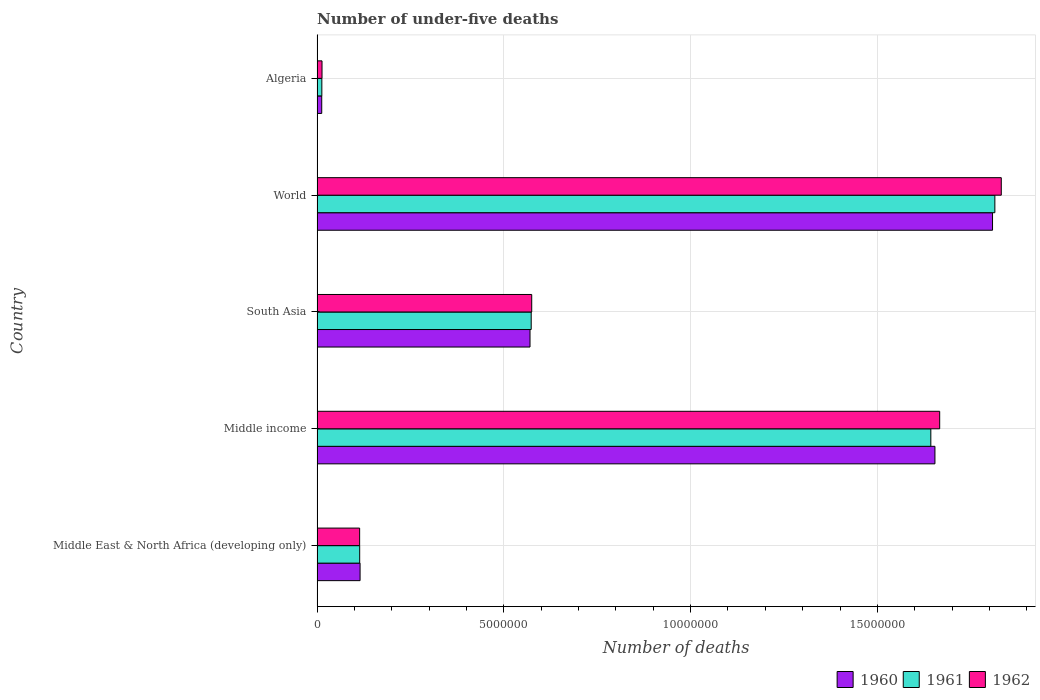How many groups of bars are there?
Make the answer very short. 5. Are the number of bars on each tick of the Y-axis equal?
Provide a short and direct response. Yes. How many bars are there on the 4th tick from the bottom?
Provide a short and direct response. 3. In how many cases, is the number of bars for a given country not equal to the number of legend labels?
Your answer should be compact. 0. What is the number of under-five deaths in 1960 in South Asia?
Your response must be concise. 5.70e+06. Across all countries, what is the maximum number of under-five deaths in 1962?
Provide a short and direct response. 1.83e+07. Across all countries, what is the minimum number of under-five deaths in 1961?
Offer a very short reply. 1.28e+05. In which country was the number of under-five deaths in 1961 maximum?
Your answer should be very brief. World. In which country was the number of under-five deaths in 1960 minimum?
Offer a terse response. Algeria. What is the total number of under-five deaths in 1960 in the graph?
Provide a short and direct response. 4.16e+07. What is the difference between the number of under-five deaths in 1960 in Middle East & North Africa (developing only) and that in World?
Your answer should be very brief. -1.69e+07. What is the difference between the number of under-five deaths in 1962 in Middle income and the number of under-five deaths in 1960 in World?
Give a very brief answer. -1.41e+06. What is the average number of under-five deaths in 1961 per country?
Provide a short and direct response. 8.32e+06. What is the difference between the number of under-five deaths in 1962 and number of under-five deaths in 1960 in Middle income?
Make the answer very short. 1.27e+05. In how many countries, is the number of under-five deaths in 1961 greater than 18000000 ?
Provide a succinct answer. 1. What is the ratio of the number of under-five deaths in 1961 in South Asia to that in World?
Make the answer very short. 0.32. Is the difference between the number of under-five deaths in 1962 in Middle East & North Africa (developing only) and Middle income greater than the difference between the number of under-five deaths in 1960 in Middle East & North Africa (developing only) and Middle income?
Ensure brevity in your answer.  No. What is the difference between the highest and the second highest number of under-five deaths in 1961?
Keep it short and to the point. 1.71e+06. What is the difference between the highest and the lowest number of under-five deaths in 1960?
Provide a succinct answer. 1.80e+07. In how many countries, is the number of under-five deaths in 1960 greater than the average number of under-five deaths in 1960 taken over all countries?
Give a very brief answer. 2. What does the 2nd bar from the top in Algeria represents?
Ensure brevity in your answer.  1961. Is it the case that in every country, the sum of the number of under-five deaths in 1961 and number of under-five deaths in 1960 is greater than the number of under-five deaths in 1962?
Provide a succinct answer. Yes. Are all the bars in the graph horizontal?
Make the answer very short. Yes. How many countries are there in the graph?
Ensure brevity in your answer.  5. Are the values on the major ticks of X-axis written in scientific E-notation?
Provide a short and direct response. No. How many legend labels are there?
Your answer should be compact. 3. What is the title of the graph?
Provide a succinct answer. Number of under-five deaths. What is the label or title of the X-axis?
Provide a short and direct response. Number of deaths. What is the label or title of the Y-axis?
Offer a very short reply. Country. What is the Number of deaths of 1960 in Middle East & North Africa (developing only)?
Provide a short and direct response. 1.15e+06. What is the Number of deaths in 1961 in Middle East & North Africa (developing only)?
Ensure brevity in your answer.  1.14e+06. What is the Number of deaths in 1962 in Middle East & North Africa (developing only)?
Your answer should be very brief. 1.14e+06. What is the Number of deaths in 1960 in Middle income?
Provide a succinct answer. 1.65e+07. What is the Number of deaths in 1961 in Middle income?
Keep it short and to the point. 1.64e+07. What is the Number of deaths in 1962 in Middle income?
Keep it short and to the point. 1.67e+07. What is the Number of deaths of 1960 in South Asia?
Make the answer very short. 5.70e+06. What is the Number of deaths of 1961 in South Asia?
Offer a very short reply. 5.73e+06. What is the Number of deaths of 1962 in South Asia?
Give a very brief answer. 5.75e+06. What is the Number of deaths in 1960 in World?
Keep it short and to the point. 1.81e+07. What is the Number of deaths of 1961 in World?
Your response must be concise. 1.81e+07. What is the Number of deaths of 1962 in World?
Offer a very short reply. 1.83e+07. What is the Number of deaths of 1960 in Algeria?
Keep it short and to the point. 1.25e+05. What is the Number of deaths of 1961 in Algeria?
Make the answer very short. 1.28e+05. What is the Number of deaths in 1962 in Algeria?
Provide a short and direct response. 1.33e+05. Across all countries, what is the maximum Number of deaths of 1960?
Make the answer very short. 1.81e+07. Across all countries, what is the maximum Number of deaths in 1961?
Keep it short and to the point. 1.81e+07. Across all countries, what is the maximum Number of deaths in 1962?
Ensure brevity in your answer.  1.83e+07. Across all countries, what is the minimum Number of deaths of 1960?
Your answer should be compact. 1.25e+05. Across all countries, what is the minimum Number of deaths of 1961?
Keep it short and to the point. 1.28e+05. Across all countries, what is the minimum Number of deaths of 1962?
Keep it short and to the point. 1.33e+05. What is the total Number of deaths of 1960 in the graph?
Give a very brief answer. 4.16e+07. What is the total Number of deaths of 1961 in the graph?
Keep it short and to the point. 4.16e+07. What is the total Number of deaths in 1962 in the graph?
Your answer should be compact. 4.20e+07. What is the difference between the Number of deaths of 1960 in Middle East & North Africa (developing only) and that in Middle income?
Offer a terse response. -1.54e+07. What is the difference between the Number of deaths of 1961 in Middle East & North Africa (developing only) and that in Middle income?
Offer a very short reply. -1.53e+07. What is the difference between the Number of deaths in 1962 in Middle East & North Africa (developing only) and that in Middle income?
Keep it short and to the point. -1.55e+07. What is the difference between the Number of deaths of 1960 in Middle East & North Africa (developing only) and that in South Asia?
Ensure brevity in your answer.  -4.55e+06. What is the difference between the Number of deaths of 1961 in Middle East & North Africa (developing only) and that in South Asia?
Provide a short and direct response. -4.59e+06. What is the difference between the Number of deaths in 1962 in Middle East & North Africa (developing only) and that in South Asia?
Provide a succinct answer. -4.61e+06. What is the difference between the Number of deaths of 1960 in Middle East & North Africa (developing only) and that in World?
Offer a terse response. -1.69e+07. What is the difference between the Number of deaths of 1961 in Middle East & North Africa (developing only) and that in World?
Give a very brief answer. -1.70e+07. What is the difference between the Number of deaths in 1962 in Middle East & North Africa (developing only) and that in World?
Provide a succinct answer. -1.72e+07. What is the difference between the Number of deaths of 1960 in Middle East & North Africa (developing only) and that in Algeria?
Provide a short and direct response. 1.03e+06. What is the difference between the Number of deaths in 1961 in Middle East & North Africa (developing only) and that in Algeria?
Offer a terse response. 1.01e+06. What is the difference between the Number of deaths in 1962 in Middle East & North Africa (developing only) and that in Algeria?
Ensure brevity in your answer.  1.01e+06. What is the difference between the Number of deaths of 1960 in Middle income and that in South Asia?
Your answer should be very brief. 1.08e+07. What is the difference between the Number of deaths of 1961 in Middle income and that in South Asia?
Give a very brief answer. 1.07e+07. What is the difference between the Number of deaths in 1962 in Middle income and that in South Asia?
Your response must be concise. 1.09e+07. What is the difference between the Number of deaths in 1960 in Middle income and that in World?
Your response must be concise. -1.54e+06. What is the difference between the Number of deaths of 1961 in Middle income and that in World?
Make the answer very short. -1.71e+06. What is the difference between the Number of deaths of 1962 in Middle income and that in World?
Offer a very short reply. -1.65e+06. What is the difference between the Number of deaths of 1960 in Middle income and that in Algeria?
Provide a succinct answer. 1.64e+07. What is the difference between the Number of deaths of 1961 in Middle income and that in Algeria?
Provide a short and direct response. 1.63e+07. What is the difference between the Number of deaths of 1962 in Middle income and that in Algeria?
Make the answer very short. 1.65e+07. What is the difference between the Number of deaths of 1960 in South Asia and that in World?
Your answer should be compact. -1.24e+07. What is the difference between the Number of deaths of 1961 in South Asia and that in World?
Ensure brevity in your answer.  -1.24e+07. What is the difference between the Number of deaths of 1962 in South Asia and that in World?
Make the answer very short. -1.26e+07. What is the difference between the Number of deaths of 1960 in South Asia and that in Algeria?
Your answer should be very brief. 5.58e+06. What is the difference between the Number of deaths in 1961 in South Asia and that in Algeria?
Offer a very short reply. 5.60e+06. What is the difference between the Number of deaths of 1962 in South Asia and that in Algeria?
Offer a terse response. 5.61e+06. What is the difference between the Number of deaths in 1960 in World and that in Algeria?
Make the answer very short. 1.80e+07. What is the difference between the Number of deaths in 1961 in World and that in Algeria?
Offer a very short reply. 1.80e+07. What is the difference between the Number of deaths in 1962 in World and that in Algeria?
Your response must be concise. 1.82e+07. What is the difference between the Number of deaths of 1960 in Middle East & North Africa (developing only) and the Number of deaths of 1961 in Middle income?
Provide a short and direct response. -1.53e+07. What is the difference between the Number of deaths in 1960 in Middle East & North Africa (developing only) and the Number of deaths in 1962 in Middle income?
Your answer should be very brief. -1.55e+07. What is the difference between the Number of deaths of 1961 in Middle East & North Africa (developing only) and the Number of deaths of 1962 in Middle income?
Offer a terse response. -1.55e+07. What is the difference between the Number of deaths in 1960 in Middle East & North Africa (developing only) and the Number of deaths in 1961 in South Asia?
Provide a succinct answer. -4.58e+06. What is the difference between the Number of deaths of 1960 in Middle East & North Africa (developing only) and the Number of deaths of 1962 in South Asia?
Make the answer very short. -4.59e+06. What is the difference between the Number of deaths of 1961 in Middle East & North Africa (developing only) and the Number of deaths of 1962 in South Asia?
Provide a short and direct response. -4.61e+06. What is the difference between the Number of deaths in 1960 in Middle East & North Africa (developing only) and the Number of deaths in 1961 in World?
Offer a very short reply. -1.70e+07. What is the difference between the Number of deaths of 1960 in Middle East & North Africa (developing only) and the Number of deaths of 1962 in World?
Make the answer very short. -1.72e+07. What is the difference between the Number of deaths in 1961 in Middle East & North Africa (developing only) and the Number of deaths in 1962 in World?
Make the answer very short. -1.72e+07. What is the difference between the Number of deaths of 1960 in Middle East & North Africa (developing only) and the Number of deaths of 1961 in Algeria?
Your answer should be very brief. 1.02e+06. What is the difference between the Number of deaths in 1960 in Middle East & North Africa (developing only) and the Number of deaths in 1962 in Algeria?
Offer a very short reply. 1.02e+06. What is the difference between the Number of deaths of 1961 in Middle East & North Africa (developing only) and the Number of deaths of 1962 in Algeria?
Make the answer very short. 1.01e+06. What is the difference between the Number of deaths in 1960 in Middle income and the Number of deaths in 1961 in South Asia?
Make the answer very short. 1.08e+07. What is the difference between the Number of deaths in 1960 in Middle income and the Number of deaths in 1962 in South Asia?
Provide a succinct answer. 1.08e+07. What is the difference between the Number of deaths of 1961 in Middle income and the Number of deaths of 1962 in South Asia?
Give a very brief answer. 1.07e+07. What is the difference between the Number of deaths of 1960 in Middle income and the Number of deaths of 1961 in World?
Your response must be concise. -1.60e+06. What is the difference between the Number of deaths of 1960 in Middle income and the Number of deaths of 1962 in World?
Make the answer very short. -1.78e+06. What is the difference between the Number of deaths of 1961 in Middle income and the Number of deaths of 1962 in World?
Keep it short and to the point. -1.89e+06. What is the difference between the Number of deaths in 1960 in Middle income and the Number of deaths in 1961 in Algeria?
Your answer should be compact. 1.64e+07. What is the difference between the Number of deaths in 1960 in Middle income and the Number of deaths in 1962 in Algeria?
Offer a terse response. 1.64e+07. What is the difference between the Number of deaths of 1961 in Middle income and the Number of deaths of 1962 in Algeria?
Offer a terse response. 1.63e+07. What is the difference between the Number of deaths in 1960 in South Asia and the Number of deaths in 1961 in World?
Your answer should be compact. -1.24e+07. What is the difference between the Number of deaths of 1960 in South Asia and the Number of deaths of 1962 in World?
Offer a very short reply. -1.26e+07. What is the difference between the Number of deaths of 1961 in South Asia and the Number of deaths of 1962 in World?
Make the answer very short. -1.26e+07. What is the difference between the Number of deaths in 1960 in South Asia and the Number of deaths in 1961 in Algeria?
Offer a very short reply. 5.57e+06. What is the difference between the Number of deaths in 1960 in South Asia and the Number of deaths in 1962 in Algeria?
Your answer should be compact. 5.57e+06. What is the difference between the Number of deaths of 1961 in South Asia and the Number of deaths of 1962 in Algeria?
Your response must be concise. 5.60e+06. What is the difference between the Number of deaths in 1960 in World and the Number of deaths in 1961 in Algeria?
Make the answer very short. 1.80e+07. What is the difference between the Number of deaths in 1960 in World and the Number of deaths in 1962 in Algeria?
Provide a succinct answer. 1.80e+07. What is the difference between the Number of deaths of 1961 in World and the Number of deaths of 1962 in Algeria?
Ensure brevity in your answer.  1.80e+07. What is the average Number of deaths of 1960 per country?
Your response must be concise. 8.32e+06. What is the average Number of deaths of 1961 per country?
Offer a terse response. 8.32e+06. What is the average Number of deaths of 1962 per country?
Offer a terse response. 8.40e+06. What is the difference between the Number of deaths in 1960 and Number of deaths in 1961 in Middle East & North Africa (developing only)?
Offer a terse response. 1.05e+04. What is the difference between the Number of deaths of 1960 and Number of deaths of 1962 in Middle East & North Africa (developing only)?
Keep it short and to the point. 1.18e+04. What is the difference between the Number of deaths of 1961 and Number of deaths of 1962 in Middle East & North Africa (developing only)?
Your answer should be compact. 1336. What is the difference between the Number of deaths in 1960 and Number of deaths in 1961 in Middle income?
Ensure brevity in your answer.  1.10e+05. What is the difference between the Number of deaths in 1960 and Number of deaths in 1962 in Middle income?
Offer a very short reply. -1.27e+05. What is the difference between the Number of deaths in 1961 and Number of deaths in 1962 in Middle income?
Your answer should be very brief. -2.37e+05. What is the difference between the Number of deaths of 1960 and Number of deaths of 1961 in South Asia?
Your response must be concise. -3.16e+04. What is the difference between the Number of deaths of 1960 and Number of deaths of 1962 in South Asia?
Give a very brief answer. -4.54e+04. What is the difference between the Number of deaths of 1961 and Number of deaths of 1962 in South Asia?
Your response must be concise. -1.37e+04. What is the difference between the Number of deaths of 1960 and Number of deaths of 1961 in World?
Keep it short and to the point. -6.21e+04. What is the difference between the Number of deaths of 1960 and Number of deaths of 1962 in World?
Make the answer very short. -2.34e+05. What is the difference between the Number of deaths in 1961 and Number of deaths in 1962 in World?
Give a very brief answer. -1.72e+05. What is the difference between the Number of deaths of 1960 and Number of deaths of 1961 in Algeria?
Provide a succinct answer. -2789. What is the difference between the Number of deaths in 1960 and Number of deaths in 1962 in Algeria?
Give a very brief answer. -7580. What is the difference between the Number of deaths of 1961 and Number of deaths of 1962 in Algeria?
Provide a succinct answer. -4791. What is the ratio of the Number of deaths in 1960 in Middle East & North Africa (developing only) to that in Middle income?
Provide a succinct answer. 0.07. What is the ratio of the Number of deaths in 1961 in Middle East & North Africa (developing only) to that in Middle income?
Provide a short and direct response. 0.07. What is the ratio of the Number of deaths in 1962 in Middle East & North Africa (developing only) to that in Middle income?
Your answer should be compact. 0.07. What is the ratio of the Number of deaths in 1960 in Middle East & North Africa (developing only) to that in South Asia?
Provide a succinct answer. 0.2. What is the ratio of the Number of deaths of 1961 in Middle East & North Africa (developing only) to that in South Asia?
Offer a terse response. 0.2. What is the ratio of the Number of deaths of 1962 in Middle East & North Africa (developing only) to that in South Asia?
Your answer should be very brief. 0.2. What is the ratio of the Number of deaths of 1960 in Middle East & North Africa (developing only) to that in World?
Your answer should be compact. 0.06. What is the ratio of the Number of deaths of 1961 in Middle East & North Africa (developing only) to that in World?
Offer a very short reply. 0.06. What is the ratio of the Number of deaths of 1962 in Middle East & North Africa (developing only) to that in World?
Offer a terse response. 0.06. What is the ratio of the Number of deaths of 1960 in Middle East & North Africa (developing only) to that in Algeria?
Provide a short and direct response. 9.18. What is the ratio of the Number of deaths in 1961 in Middle East & North Africa (developing only) to that in Algeria?
Provide a short and direct response. 8.9. What is the ratio of the Number of deaths of 1962 in Middle East & North Africa (developing only) to that in Algeria?
Your answer should be compact. 8.57. What is the ratio of the Number of deaths in 1960 in Middle income to that in South Asia?
Ensure brevity in your answer.  2.9. What is the ratio of the Number of deaths of 1961 in Middle income to that in South Asia?
Provide a succinct answer. 2.87. What is the ratio of the Number of deaths in 1962 in Middle income to that in South Asia?
Your response must be concise. 2.9. What is the ratio of the Number of deaths of 1960 in Middle income to that in World?
Your answer should be compact. 0.91. What is the ratio of the Number of deaths in 1961 in Middle income to that in World?
Offer a terse response. 0.91. What is the ratio of the Number of deaths of 1962 in Middle income to that in World?
Offer a very short reply. 0.91. What is the ratio of the Number of deaths of 1960 in Middle income to that in Algeria?
Your response must be concise. 131.85. What is the ratio of the Number of deaths of 1961 in Middle income to that in Algeria?
Give a very brief answer. 128.13. What is the ratio of the Number of deaths of 1962 in Middle income to that in Algeria?
Provide a short and direct response. 125.3. What is the ratio of the Number of deaths of 1960 in South Asia to that in World?
Your answer should be very brief. 0.32. What is the ratio of the Number of deaths in 1961 in South Asia to that in World?
Your answer should be compact. 0.32. What is the ratio of the Number of deaths of 1962 in South Asia to that in World?
Give a very brief answer. 0.31. What is the ratio of the Number of deaths of 1960 in South Asia to that in Algeria?
Provide a succinct answer. 45.45. What is the ratio of the Number of deaths in 1961 in South Asia to that in Algeria?
Offer a terse response. 44.7. What is the ratio of the Number of deaths in 1962 in South Asia to that in Algeria?
Your answer should be very brief. 43.2. What is the ratio of the Number of deaths in 1960 in World to that in Algeria?
Provide a short and direct response. 144.14. What is the ratio of the Number of deaths in 1961 in World to that in Algeria?
Make the answer very short. 141.49. What is the ratio of the Number of deaths in 1962 in World to that in Algeria?
Provide a succinct answer. 137.69. What is the difference between the highest and the second highest Number of deaths of 1960?
Give a very brief answer. 1.54e+06. What is the difference between the highest and the second highest Number of deaths in 1961?
Your response must be concise. 1.71e+06. What is the difference between the highest and the second highest Number of deaths in 1962?
Provide a short and direct response. 1.65e+06. What is the difference between the highest and the lowest Number of deaths of 1960?
Ensure brevity in your answer.  1.80e+07. What is the difference between the highest and the lowest Number of deaths of 1961?
Keep it short and to the point. 1.80e+07. What is the difference between the highest and the lowest Number of deaths in 1962?
Offer a very short reply. 1.82e+07. 